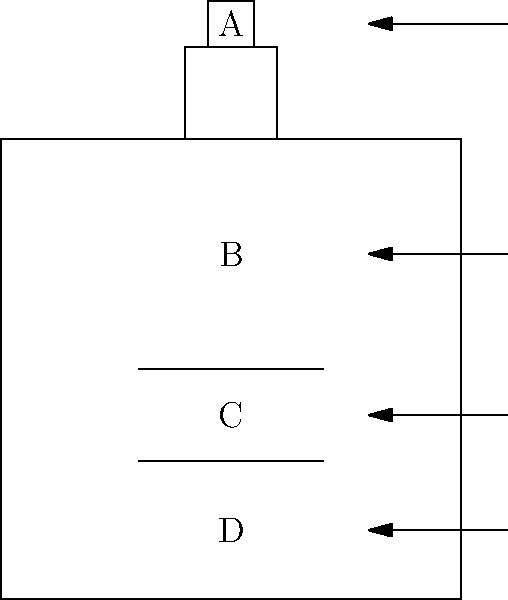In this simplified diagram of a laboratory apparatus setup, identify the component labeled 'C' that is typically used for sample preparation or reaction initiation in spectroscopic experiments. To identify the component labeled 'C' in this simplified laboratory apparatus setup, let's analyze the diagram step-by-step:

1. Component A: This appears to be a small container or vessel at the top of the setup. In spectroscopic experiments, this is often a sample introduction system or a reagent reservoir.

2. Component B: This is the largest section of the apparatus, likely representing the main reaction chamber or spectroscopic cell.

3. Component C: This component is positioned in the lower half of the main chamber. It consists of two parallel lines, which is a common representation of a cuvette or sample holder in spectroscopic setups.

4. Component D: This is at the bottom of the setup, possibly representing a detection system or waste collection area.

Given the question's focus on sample preparation or reaction initiation in spectroscopic experiments, component C is the most likely candidate. In spectroscopy, cuvettes are crucial for holding samples during analysis or for initiating reactions by mixing reagents.

Cuvettes are typically small, rectangular containers with transparent sides that allow light to pass through for spectroscopic measurements. They are essential for preparing and positioning samples in the path of the light beam in various spectroscopic techniques such as UV-Vis spectroscopy, fluorescence spectroscopy, and others.

Therefore, the component labeled 'C' in this diagram most likely represents a cuvette or sample holder, which is indeed used for sample preparation and reaction initiation in many spectroscopic experiments.
Answer: Cuvette 